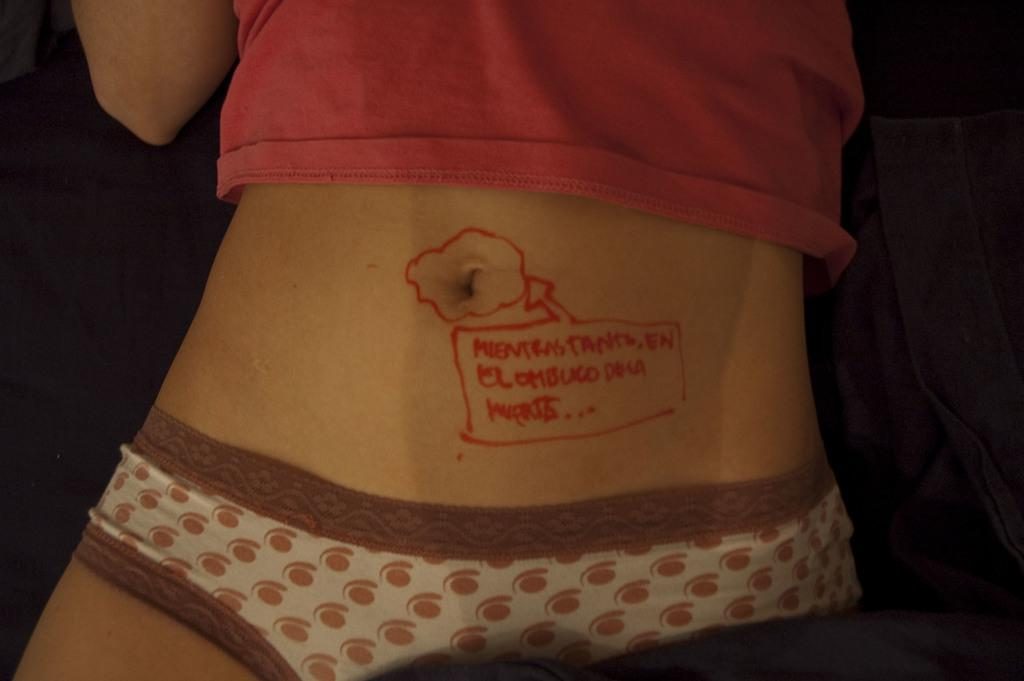What is present in the image? There is a person in the image. What is the person wearing? The person is wearing a pink dress. Where is the cemetery located in the image? There is no cemetery present in the image; it only features a person wearing a pink dress. What type of art can be seen in the image? There is no art present in the image; it only features a person wearing a pink dress. 